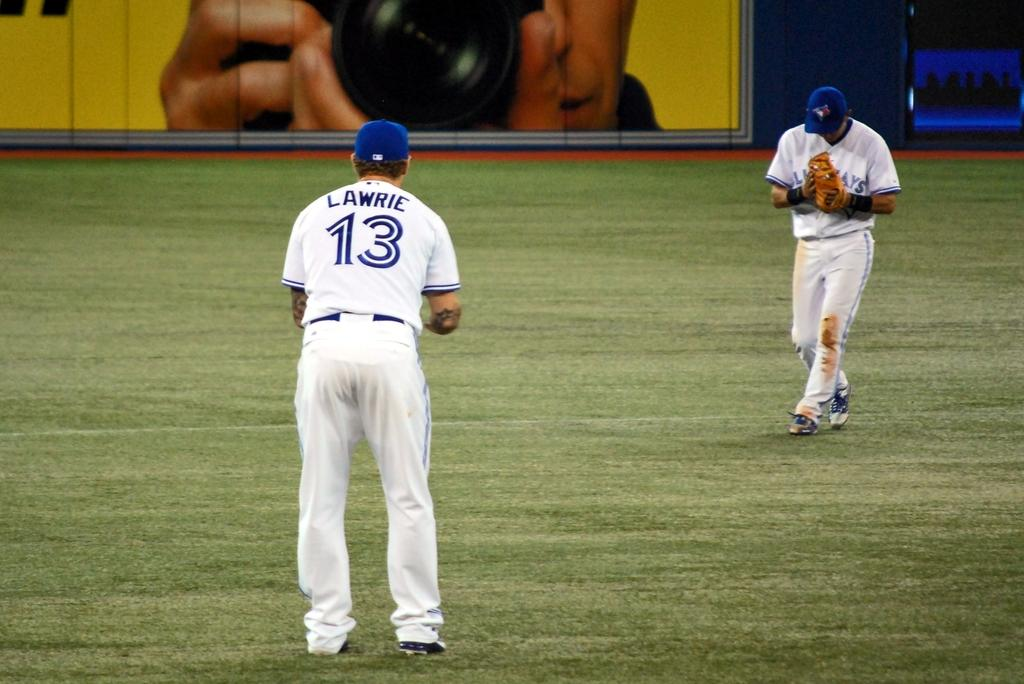Provide a one-sentence caption for the provided image. some baseball players and one with the number 13 on them. 